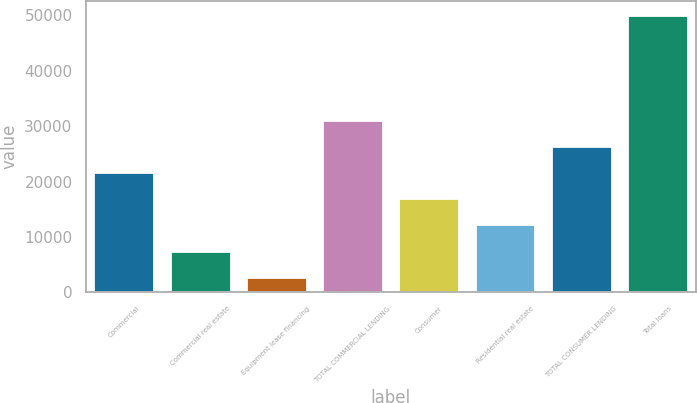Convert chart to OTSL. <chart><loc_0><loc_0><loc_500><loc_500><bar_chart><fcel>Commercial<fcel>Commercial real estate<fcel>Equipment lease financing<fcel>TOTAL COMMERCIAL LENDING<fcel>Consumer<fcel>Residential real estate<fcel>TOTAL CONSUMER LENDING<fcel>Total loans<nl><fcel>21715.4<fcel>7520.6<fcel>2789<fcel>31178.6<fcel>16983.8<fcel>12252.2<fcel>26447<fcel>50105<nl></chart> 